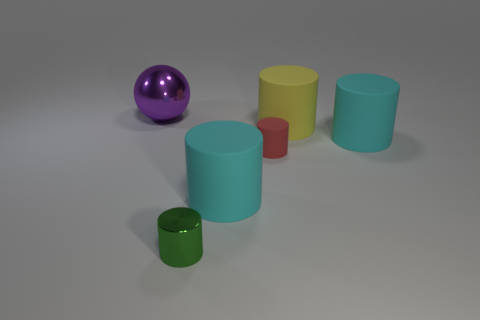Subtract all large cyan rubber cylinders. How many cylinders are left? 3 Subtract all yellow cylinders. How many cylinders are left? 4 Add 3 tiny gray balls. How many objects exist? 9 Subtract 0 green spheres. How many objects are left? 6 Subtract all cylinders. How many objects are left? 1 Subtract 1 balls. How many balls are left? 0 Subtract all brown cylinders. Subtract all cyan spheres. How many cylinders are left? 5 Subtract all purple spheres. How many red cylinders are left? 1 Subtract all green objects. Subtract all rubber objects. How many objects are left? 1 Add 1 large cylinders. How many large cylinders are left? 4 